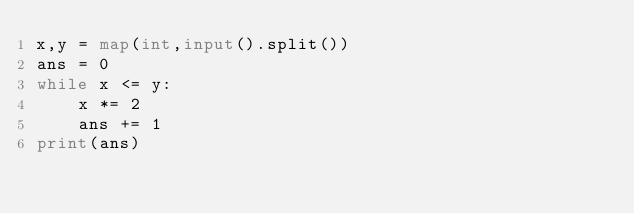<code> <loc_0><loc_0><loc_500><loc_500><_Python_>x,y = map(int,input().split())
ans = 0
while x <= y:
    x *= 2
    ans += 1
print(ans)
</code> 